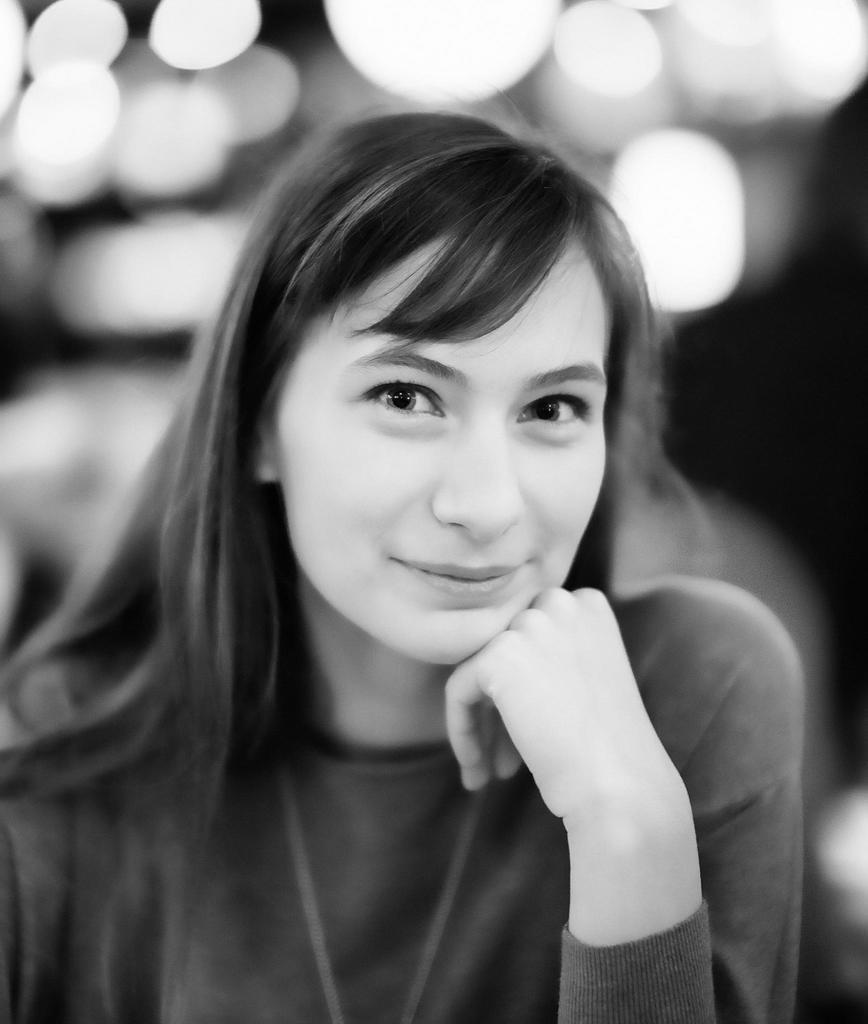Who is present in the image? There is a woman in the image. What expression does the woman have? The woman is smiling. What can be seen in the background of the image? There are lights visible in the background of the image. What type of quilt is the woman holding in the image? There is no quilt present in the image; the woman is not holding any object. Is the woman walking in the rain in the image? There is no rain present in the image, and the woman is not walking. 